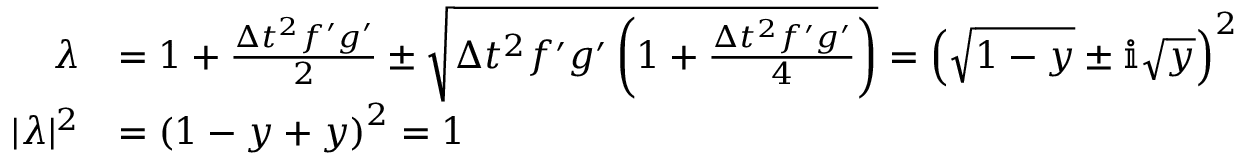<formula> <loc_0><loc_0><loc_500><loc_500>\begin{array} { r l } { \lambda } & { = 1 + \frac { \Delta t ^ { 2 } f ^ { \prime } g ^ { \prime } } { 2 } \pm \sqrt { \Delta t ^ { 2 } f ^ { \prime } g ^ { \prime } \left ( 1 + \frac { \Delta t ^ { 2 } f ^ { \prime } g ^ { \prime } } { 4 } \right ) } = \left ( \sqrt { 1 - y } \pm \mathbb { i } \sqrt { y } \right ) ^ { 2 } } \\ { | \lambda | ^ { 2 } } & { = \left ( 1 - y + y \right ) ^ { 2 } = 1 } \end{array}</formula> 